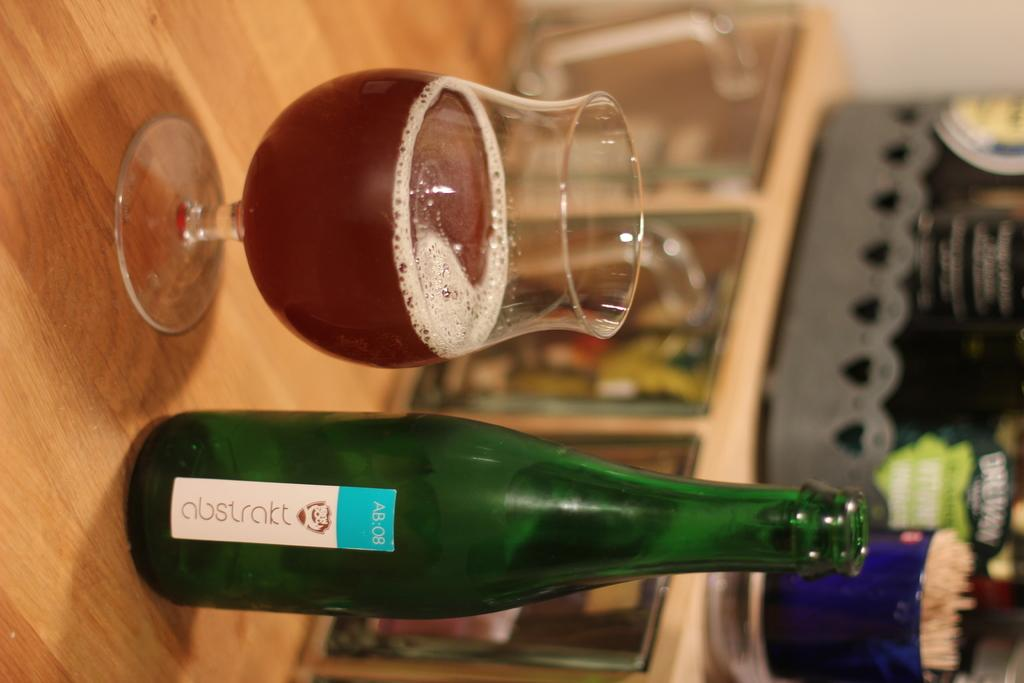Provide a one-sentence caption for the provided image. A cup filled with liquor from a bottle of Abstrakt sitting on a table. 